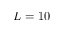<formula> <loc_0><loc_0><loc_500><loc_500>L = 1 0</formula> 